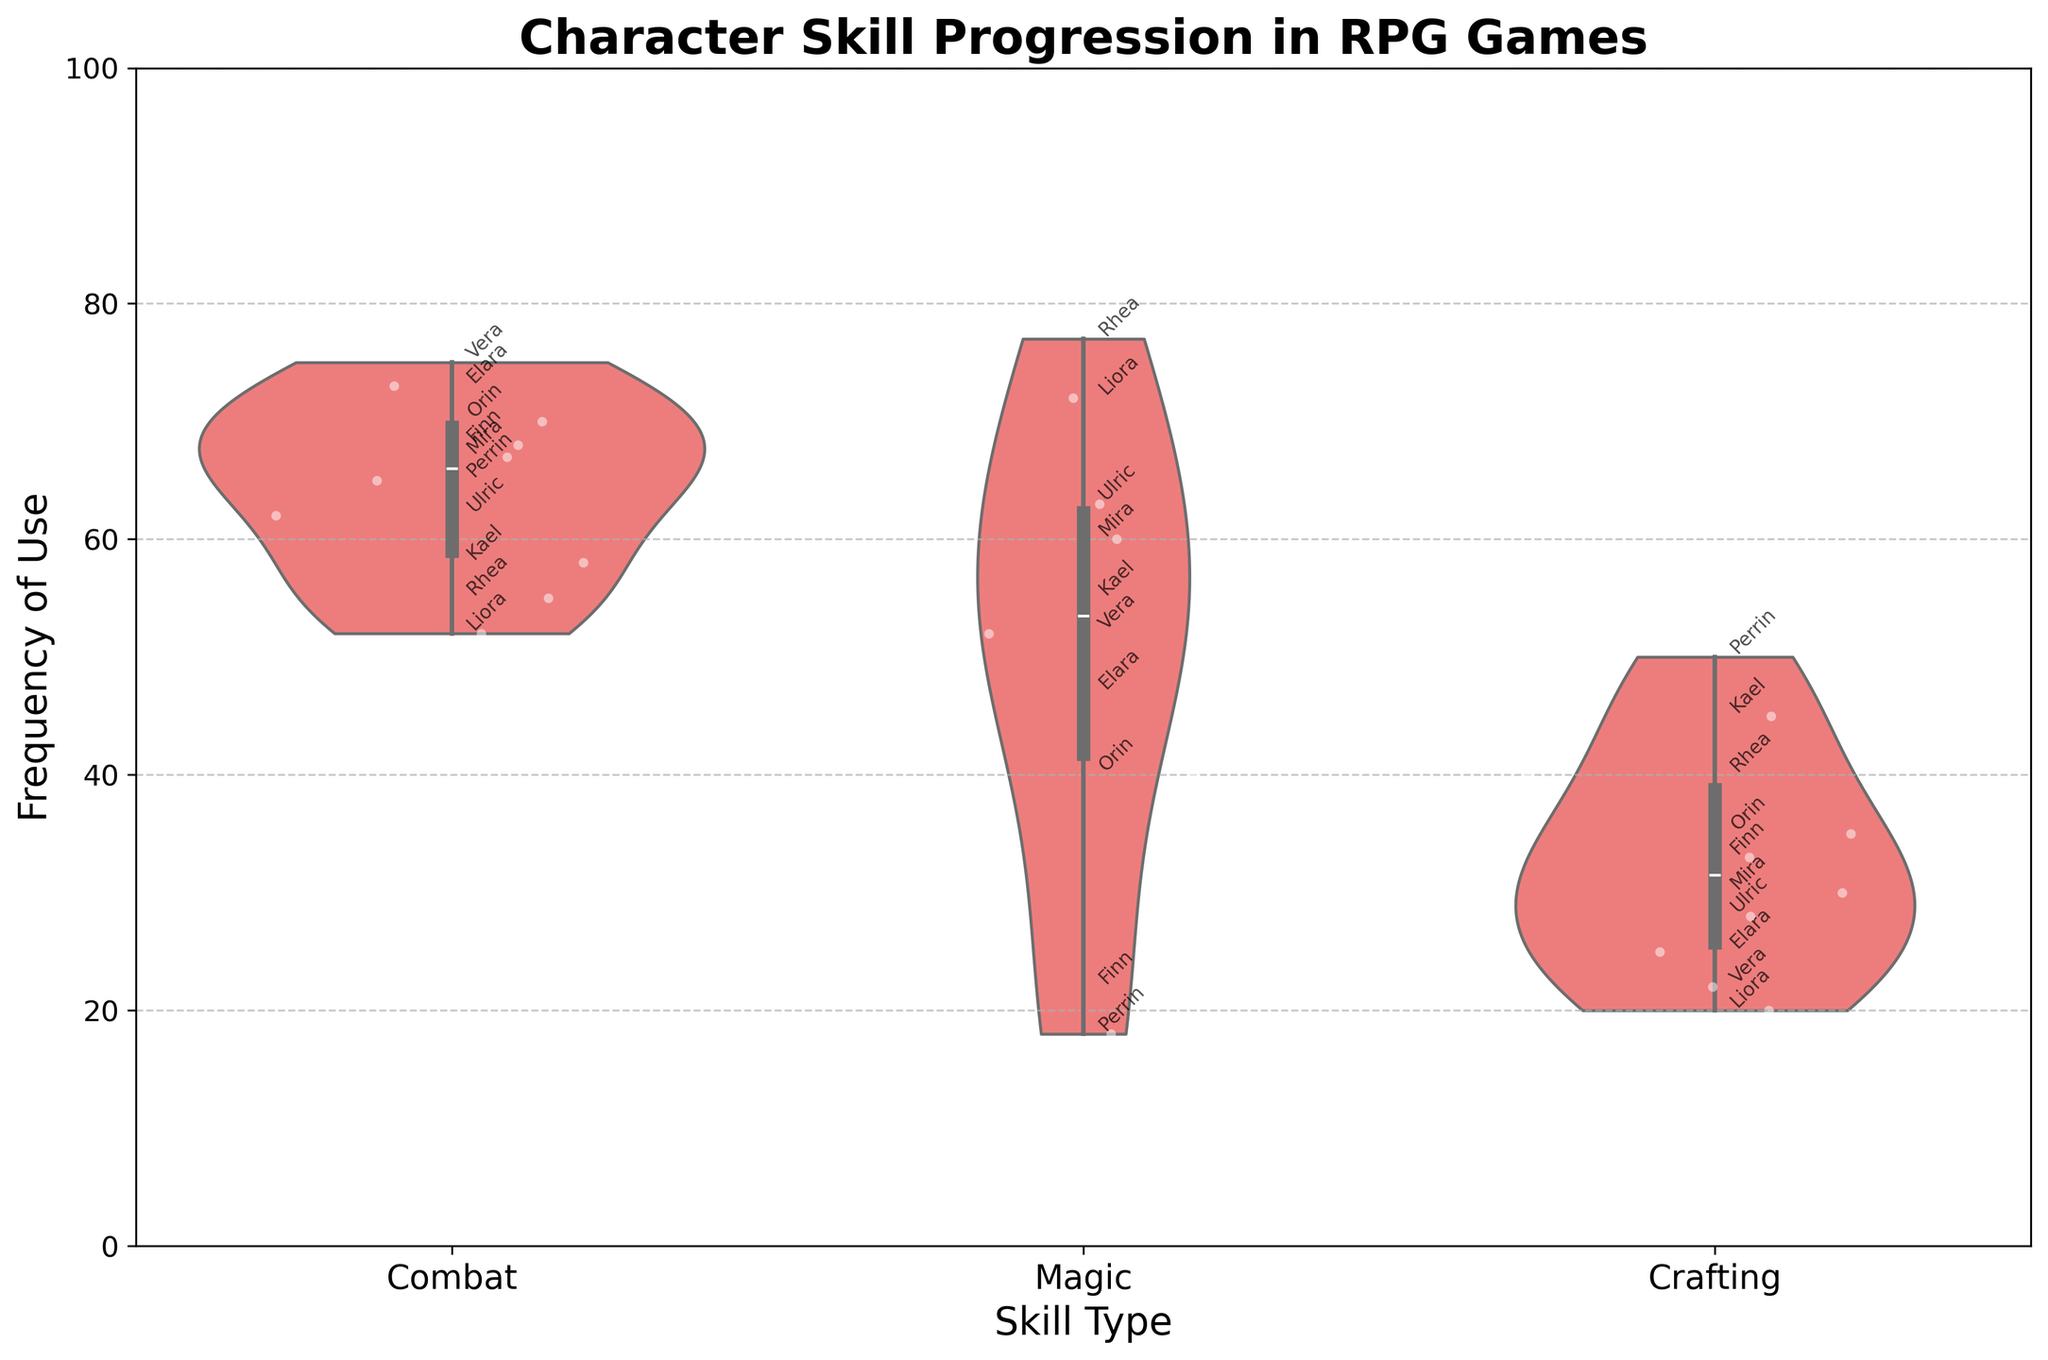what is the title of the plot? The title of the plot is displayed at the top center of the figure, which reads "Character Skill Progression in RPG Games".
Answer: Character Skill Progression in RPG Games What are the skill types shown on the x-axis? The x-axis has labels for the skill types, which are 'Combat', 'Magic', and 'Crafting'.
Answer: Combat, Magic, Crafting What color is used for the jittered points? The jittered points for all data points are colored white and are semi-transparent.
Answer: White Which character has the highest frequency of use for the Magic skill? To find the character with the highest frequency of use for the Magic skill, look at the data points within the 'Magic' violin plot. The highest point annotated with a character's name is 'Rhea' at 77.
Answer: Rhea What is the range of frequencies for the Crafting skill? The range can be determined by looking at the spread of the data points within the 'Crafting' violin plot. The lowest point is 20 (Liora) and the highest is 50 (Perrin). Therefore, the range is 20 to 50.
Answer: 20 to 50 How does Vera's frequency of use for Combat compare to Ulric's? Identify the data points for Vera and Ulric within the 'Combat' violin plot. Vera's frequency is 75, while Ulric's is 62. Vera's frequency of use is higher than Ulric's.
Answer: Vera has a higher frequency For which skill is the spread of frequencies the widest? The spread of frequencies can be inferred by looking at the width and length of each violin plot. The 'Magic' skill shows the widest range from 18 (Perrin) to 77 (Rhea).
Answer: Magic What is the median frequency of use for the Combat skill? The median frequency can be estimated by the thickest part of the 'Combat' violin plot. The median value appears to be close to 65.
Answer: Around 65 How many times does Elara appear in the figure and for which skills? Elara's name appears three times in the figure, once for each skill type: Combat, Magic, and Crafting.
Answer: Three times, in Combat, Magic, and Crafting 